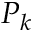Convert formula to latex. <formula><loc_0><loc_0><loc_500><loc_500>P _ { k }</formula> 